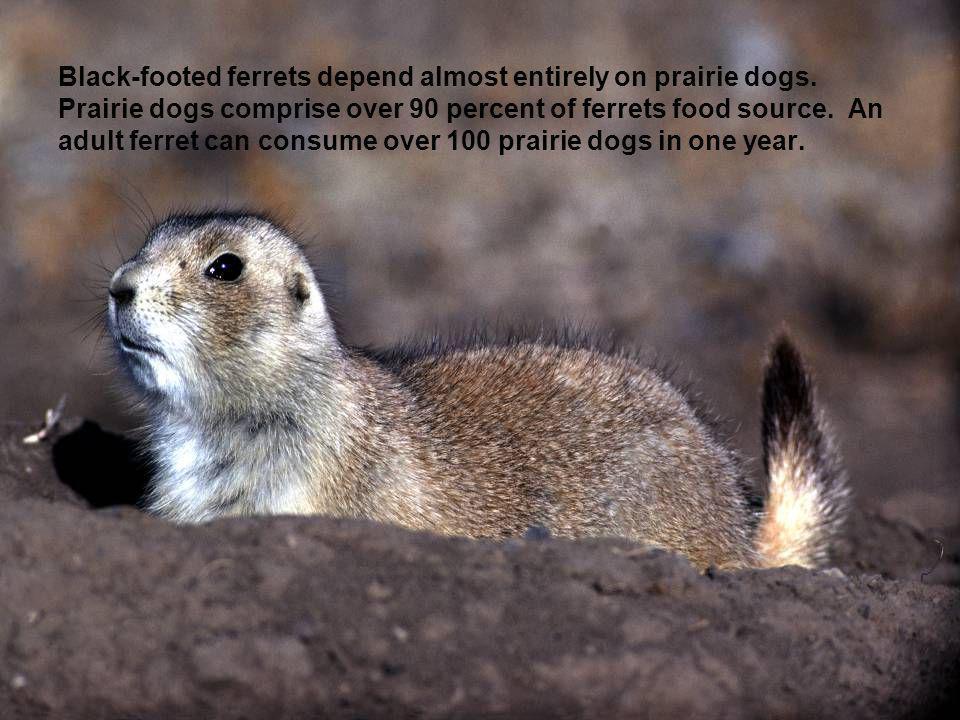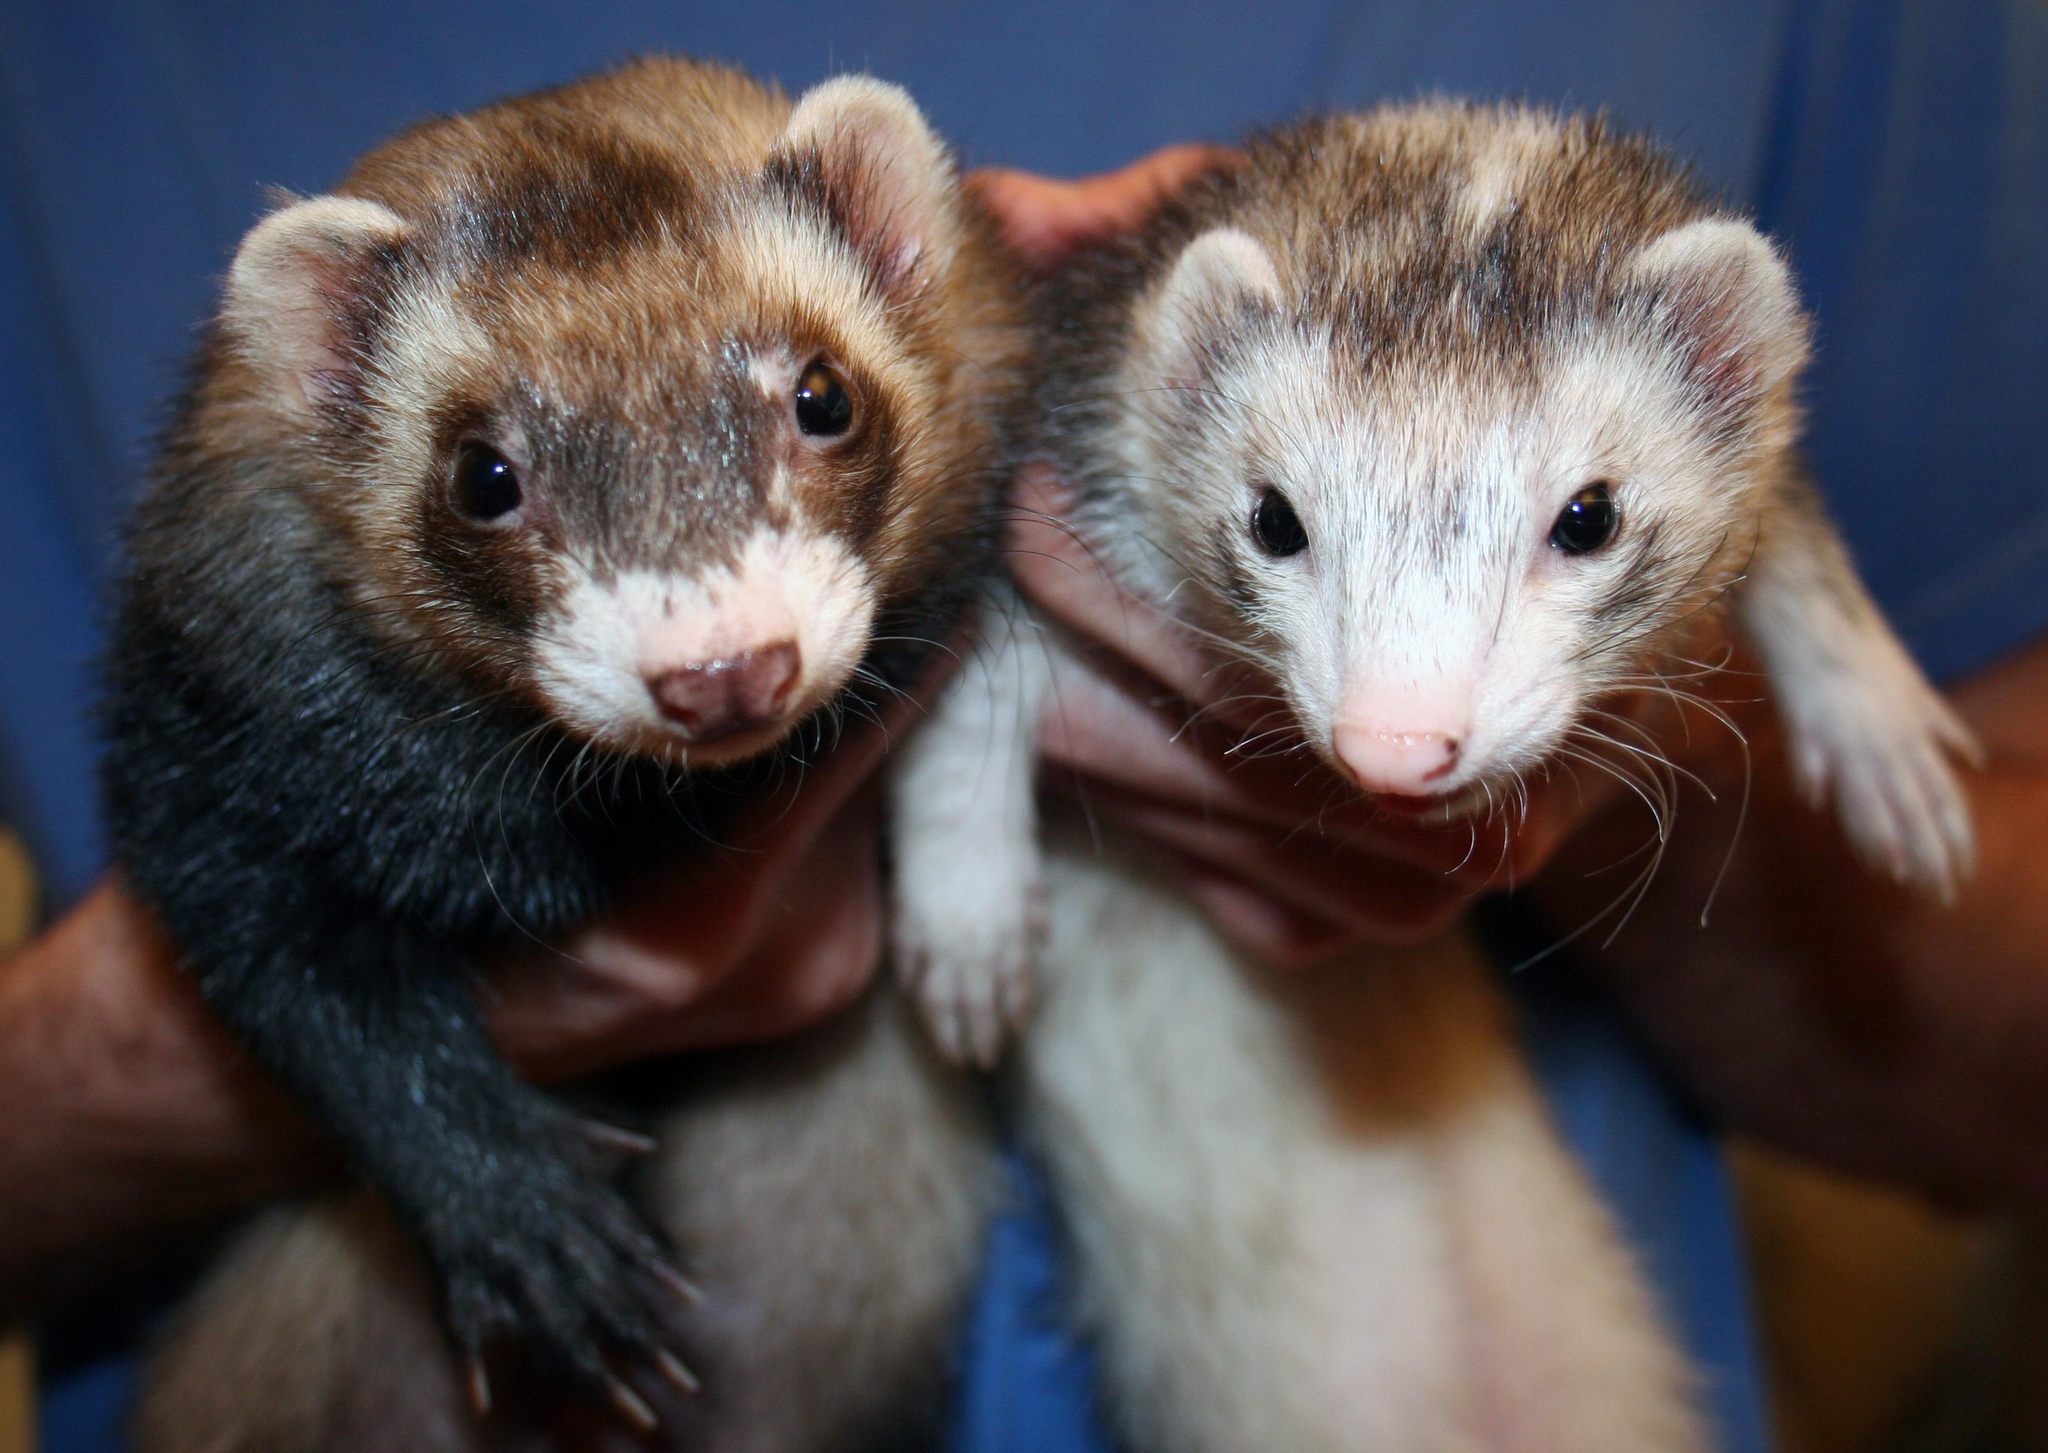The first image is the image on the left, the second image is the image on the right. Evaluate the accuracy of this statement regarding the images: "The right image contains at least two ferrets.". Is it true? Answer yes or no. Yes. The first image is the image on the left, the second image is the image on the right. For the images shown, is this caption "There are more animals in the image on the right." true? Answer yes or no. Yes. 